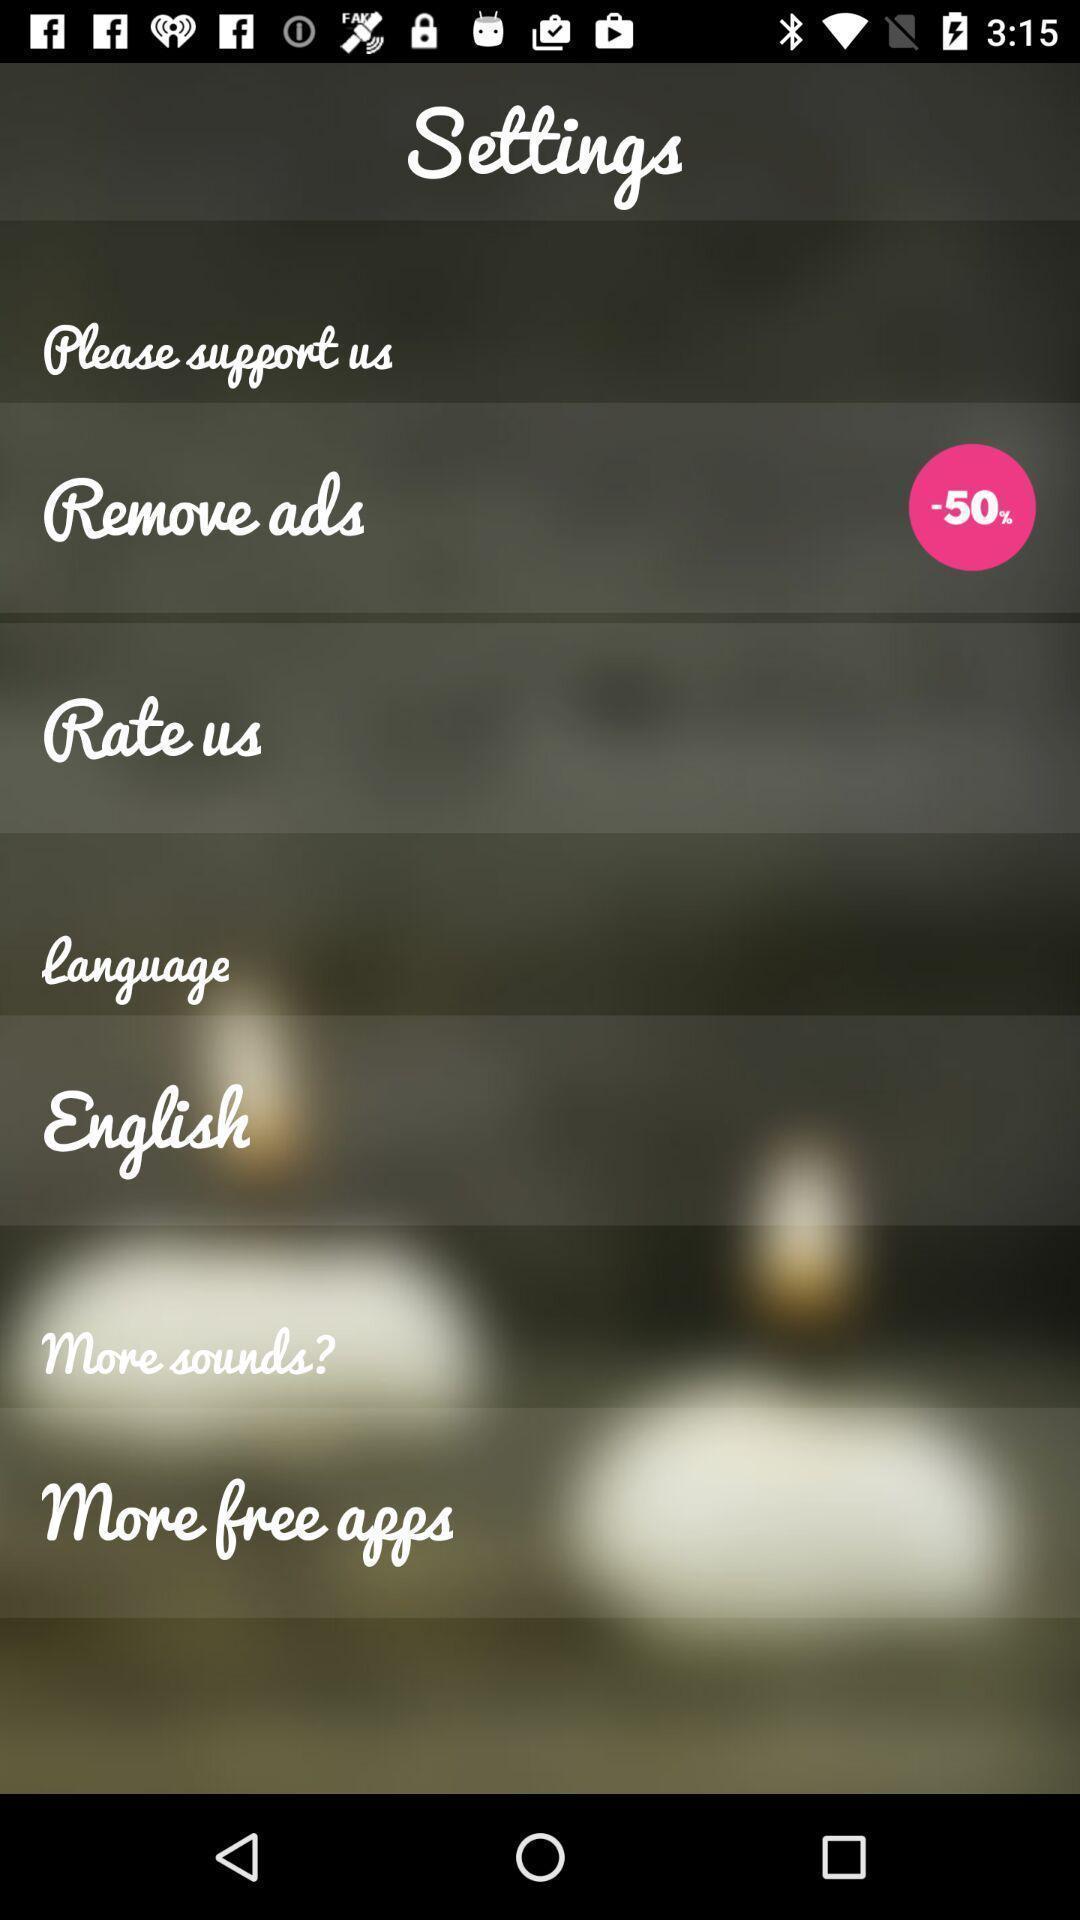Summarize the information in this screenshot. Screen shows settings. 